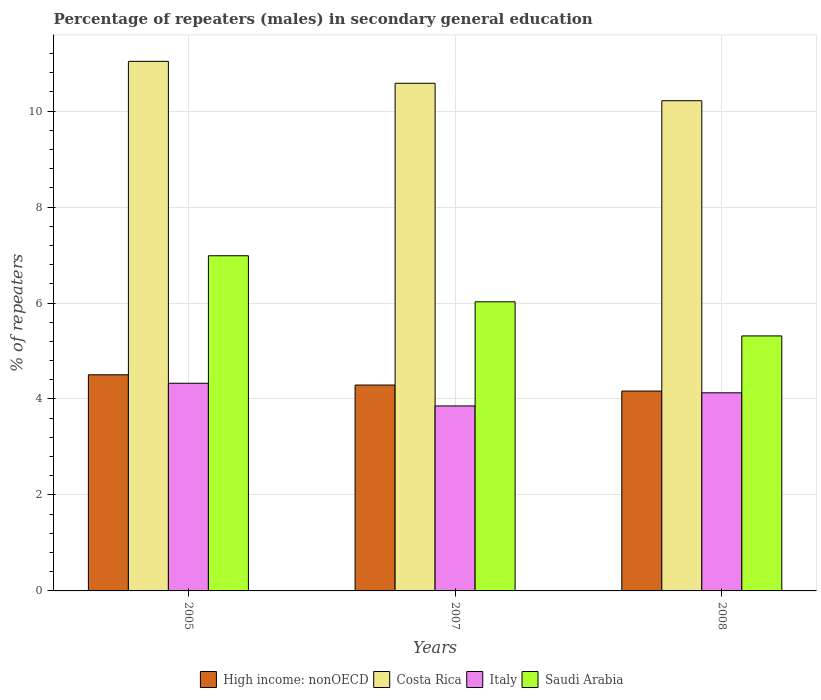How many different coloured bars are there?
Your answer should be very brief. 4. How many groups of bars are there?
Your answer should be very brief. 3. What is the percentage of male repeaters in High income: nonOECD in 2007?
Keep it short and to the point. 4.29. Across all years, what is the maximum percentage of male repeaters in Costa Rica?
Provide a succinct answer. 11.04. Across all years, what is the minimum percentage of male repeaters in Italy?
Your response must be concise. 3.86. In which year was the percentage of male repeaters in High income: nonOECD minimum?
Your answer should be compact. 2008. What is the total percentage of male repeaters in Italy in the graph?
Your response must be concise. 12.31. What is the difference between the percentage of male repeaters in Saudi Arabia in 2005 and that in 2007?
Give a very brief answer. 0.96. What is the difference between the percentage of male repeaters in Saudi Arabia in 2007 and the percentage of male repeaters in Italy in 2005?
Your answer should be very brief. 1.7. What is the average percentage of male repeaters in High income: nonOECD per year?
Offer a very short reply. 4.32. In the year 2007, what is the difference between the percentage of male repeaters in Saudi Arabia and percentage of male repeaters in Italy?
Your response must be concise. 2.17. What is the ratio of the percentage of male repeaters in High income: nonOECD in 2005 to that in 2007?
Your answer should be very brief. 1.05. Is the percentage of male repeaters in Costa Rica in 2007 less than that in 2008?
Your answer should be compact. No. What is the difference between the highest and the second highest percentage of male repeaters in High income: nonOECD?
Your answer should be compact. 0.21. What is the difference between the highest and the lowest percentage of male repeaters in Costa Rica?
Your answer should be very brief. 0.82. Is the sum of the percentage of male repeaters in High income: nonOECD in 2007 and 2008 greater than the maximum percentage of male repeaters in Costa Rica across all years?
Your response must be concise. No. Is it the case that in every year, the sum of the percentage of male repeaters in Italy and percentage of male repeaters in Costa Rica is greater than the sum of percentage of male repeaters in Saudi Arabia and percentage of male repeaters in High income: nonOECD?
Provide a short and direct response. Yes. What does the 1st bar from the right in 2008 represents?
Make the answer very short. Saudi Arabia. How many years are there in the graph?
Keep it short and to the point. 3. Are the values on the major ticks of Y-axis written in scientific E-notation?
Make the answer very short. No. Where does the legend appear in the graph?
Offer a very short reply. Bottom center. How are the legend labels stacked?
Make the answer very short. Horizontal. What is the title of the graph?
Make the answer very short. Percentage of repeaters (males) in secondary general education. Does "Trinidad and Tobago" appear as one of the legend labels in the graph?
Ensure brevity in your answer.  No. What is the label or title of the Y-axis?
Offer a very short reply. % of repeaters. What is the % of repeaters in High income: nonOECD in 2005?
Keep it short and to the point. 4.5. What is the % of repeaters of Costa Rica in 2005?
Give a very brief answer. 11.04. What is the % of repeaters of Italy in 2005?
Provide a succinct answer. 4.33. What is the % of repeaters in Saudi Arabia in 2005?
Your answer should be compact. 6.99. What is the % of repeaters of High income: nonOECD in 2007?
Your answer should be compact. 4.29. What is the % of repeaters of Costa Rica in 2007?
Offer a very short reply. 10.58. What is the % of repeaters of Italy in 2007?
Provide a succinct answer. 3.86. What is the % of repeaters in Saudi Arabia in 2007?
Give a very brief answer. 6.03. What is the % of repeaters of High income: nonOECD in 2008?
Offer a very short reply. 4.17. What is the % of repeaters in Costa Rica in 2008?
Provide a succinct answer. 10.22. What is the % of repeaters of Italy in 2008?
Your response must be concise. 4.13. What is the % of repeaters of Saudi Arabia in 2008?
Your response must be concise. 5.31. Across all years, what is the maximum % of repeaters in High income: nonOECD?
Your response must be concise. 4.5. Across all years, what is the maximum % of repeaters of Costa Rica?
Your answer should be compact. 11.04. Across all years, what is the maximum % of repeaters of Italy?
Your answer should be compact. 4.33. Across all years, what is the maximum % of repeaters of Saudi Arabia?
Make the answer very short. 6.99. Across all years, what is the minimum % of repeaters of High income: nonOECD?
Give a very brief answer. 4.17. Across all years, what is the minimum % of repeaters of Costa Rica?
Give a very brief answer. 10.22. Across all years, what is the minimum % of repeaters of Italy?
Make the answer very short. 3.86. Across all years, what is the minimum % of repeaters of Saudi Arabia?
Provide a succinct answer. 5.31. What is the total % of repeaters in High income: nonOECD in the graph?
Give a very brief answer. 12.96. What is the total % of repeaters in Costa Rica in the graph?
Keep it short and to the point. 31.83. What is the total % of repeaters of Italy in the graph?
Your response must be concise. 12.31. What is the total % of repeaters in Saudi Arabia in the graph?
Offer a terse response. 18.32. What is the difference between the % of repeaters of High income: nonOECD in 2005 and that in 2007?
Provide a succinct answer. 0.21. What is the difference between the % of repeaters in Costa Rica in 2005 and that in 2007?
Ensure brevity in your answer.  0.46. What is the difference between the % of repeaters in Italy in 2005 and that in 2007?
Offer a very short reply. 0.47. What is the difference between the % of repeaters of Saudi Arabia in 2005 and that in 2007?
Offer a very short reply. 0.96. What is the difference between the % of repeaters of High income: nonOECD in 2005 and that in 2008?
Offer a very short reply. 0.34. What is the difference between the % of repeaters of Costa Rica in 2005 and that in 2008?
Offer a terse response. 0.82. What is the difference between the % of repeaters of Italy in 2005 and that in 2008?
Give a very brief answer. 0.2. What is the difference between the % of repeaters in Saudi Arabia in 2005 and that in 2008?
Keep it short and to the point. 1.67. What is the difference between the % of repeaters of High income: nonOECD in 2007 and that in 2008?
Offer a terse response. 0.13. What is the difference between the % of repeaters in Costa Rica in 2007 and that in 2008?
Give a very brief answer. 0.36. What is the difference between the % of repeaters of Italy in 2007 and that in 2008?
Provide a succinct answer. -0.27. What is the difference between the % of repeaters in Saudi Arabia in 2007 and that in 2008?
Ensure brevity in your answer.  0.71. What is the difference between the % of repeaters in High income: nonOECD in 2005 and the % of repeaters in Costa Rica in 2007?
Offer a very short reply. -6.08. What is the difference between the % of repeaters in High income: nonOECD in 2005 and the % of repeaters in Italy in 2007?
Offer a very short reply. 0.65. What is the difference between the % of repeaters of High income: nonOECD in 2005 and the % of repeaters of Saudi Arabia in 2007?
Your answer should be very brief. -1.52. What is the difference between the % of repeaters of Costa Rica in 2005 and the % of repeaters of Italy in 2007?
Provide a succinct answer. 7.18. What is the difference between the % of repeaters of Costa Rica in 2005 and the % of repeaters of Saudi Arabia in 2007?
Your answer should be very brief. 5.01. What is the difference between the % of repeaters of Italy in 2005 and the % of repeaters of Saudi Arabia in 2007?
Keep it short and to the point. -1.7. What is the difference between the % of repeaters in High income: nonOECD in 2005 and the % of repeaters in Costa Rica in 2008?
Your answer should be very brief. -5.71. What is the difference between the % of repeaters in High income: nonOECD in 2005 and the % of repeaters in Italy in 2008?
Your answer should be very brief. 0.38. What is the difference between the % of repeaters of High income: nonOECD in 2005 and the % of repeaters of Saudi Arabia in 2008?
Your response must be concise. -0.81. What is the difference between the % of repeaters of Costa Rica in 2005 and the % of repeaters of Italy in 2008?
Offer a very short reply. 6.91. What is the difference between the % of repeaters of Costa Rica in 2005 and the % of repeaters of Saudi Arabia in 2008?
Your answer should be compact. 5.72. What is the difference between the % of repeaters in Italy in 2005 and the % of repeaters in Saudi Arabia in 2008?
Your answer should be very brief. -0.99. What is the difference between the % of repeaters in High income: nonOECD in 2007 and the % of repeaters in Costa Rica in 2008?
Your answer should be very brief. -5.93. What is the difference between the % of repeaters of High income: nonOECD in 2007 and the % of repeaters of Italy in 2008?
Keep it short and to the point. 0.16. What is the difference between the % of repeaters in High income: nonOECD in 2007 and the % of repeaters in Saudi Arabia in 2008?
Your answer should be very brief. -1.02. What is the difference between the % of repeaters of Costa Rica in 2007 and the % of repeaters of Italy in 2008?
Offer a terse response. 6.45. What is the difference between the % of repeaters in Costa Rica in 2007 and the % of repeaters in Saudi Arabia in 2008?
Your answer should be compact. 5.27. What is the difference between the % of repeaters in Italy in 2007 and the % of repeaters in Saudi Arabia in 2008?
Keep it short and to the point. -1.46. What is the average % of repeaters in High income: nonOECD per year?
Your response must be concise. 4.32. What is the average % of repeaters of Costa Rica per year?
Your answer should be very brief. 10.61. What is the average % of repeaters of Italy per year?
Offer a terse response. 4.1. What is the average % of repeaters of Saudi Arabia per year?
Offer a very short reply. 6.11. In the year 2005, what is the difference between the % of repeaters in High income: nonOECD and % of repeaters in Costa Rica?
Provide a short and direct response. -6.53. In the year 2005, what is the difference between the % of repeaters in High income: nonOECD and % of repeaters in Italy?
Your response must be concise. 0.18. In the year 2005, what is the difference between the % of repeaters in High income: nonOECD and % of repeaters in Saudi Arabia?
Your answer should be compact. -2.48. In the year 2005, what is the difference between the % of repeaters of Costa Rica and % of repeaters of Italy?
Your answer should be compact. 6.71. In the year 2005, what is the difference between the % of repeaters in Costa Rica and % of repeaters in Saudi Arabia?
Make the answer very short. 4.05. In the year 2005, what is the difference between the % of repeaters in Italy and % of repeaters in Saudi Arabia?
Offer a very short reply. -2.66. In the year 2007, what is the difference between the % of repeaters in High income: nonOECD and % of repeaters in Costa Rica?
Your answer should be compact. -6.29. In the year 2007, what is the difference between the % of repeaters of High income: nonOECD and % of repeaters of Italy?
Your answer should be very brief. 0.44. In the year 2007, what is the difference between the % of repeaters in High income: nonOECD and % of repeaters in Saudi Arabia?
Provide a short and direct response. -1.73. In the year 2007, what is the difference between the % of repeaters in Costa Rica and % of repeaters in Italy?
Provide a succinct answer. 6.72. In the year 2007, what is the difference between the % of repeaters in Costa Rica and % of repeaters in Saudi Arabia?
Provide a short and direct response. 4.55. In the year 2007, what is the difference between the % of repeaters of Italy and % of repeaters of Saudi Arabia?
Your response must be concise. -2.17. In the year 2008, what is the difference between the % of repeaters in High income: nonOECD and % of repeaters in Costa Rica?
Provide a succinct answer. -6.05. In the year 2008, what is the difference between the % of repeaters in High income: nonOECD and % of repeaters in Italy?
Provide a succinct answer. 0.04. In the year 2008, what is the difference between the % of repeaters in High income: nonOECD and % of repeaters in Saudi Arabia?
Give a very brief answer. -1.15. In the year 2008, what is the difference between the % of repeaters of Costa Rica and % of repeaters of Italy?
Offer a very short reply. 6.09. In the year 2008, what is the difference between the % of repeaters in Costa Rica and % of repeaters in Saudi Arabia?
Keep it short and to the point. 4.9. In the year 2008, what is the difference between the % of repeaters in Italy and % of repeaters in Saudi Arabia?
Offer a very short reply. -1.19. What is the ratio of the % of repeaters of High income: nonOECD in 2005 to that in 2007?
Offer a very short reply. 1.05. What is the ratio of the % of repeaters in Costa Rica in 2005 to that in 2007?
Ensure brevity in your answer.  1.04. What is the ratio of the % of repeaters in Italy in 2005 to that in 2007?
Keep it short and to the point. 1.12. What is the ratio of the % of repeaters in Saudi Arabia in 2005 to that in 2007?
Make the answer very short. 1.16. What is the ratio of the % of repeaters of High income: nonOECD in 2005 to that in 2008?
Provide a succinct answer. 1.08. What is the ratio of the % of repeaters in Costa Rica in 2005 to that in 2008?
Your response must be concise. 1.08. What is the ratio of the % of repeaters in Italy in 2005 to that in 2008?
Keep it short and to the point. 1.05. What is the ratio of the % of repeaters of Saudi Arabia in 2005 to that in 2008?
Ensure brevity in your answer.  1.31. What is the ratio of the % of repeaters of High income: nonOECD in 2007 to that in 2008?
Offer a terse response. 1.03. What is the ratio of the % of repeaters of Costa Rica in 2007 to that in 2008?
Keep it short and to the point. 1.04. What is the ratio of the % of repeaters in Italy in 2007 to that in 2008?
Keep it short and to the point. 0.93. What is the ratio of the % of repeaters of Saudi Arabia in 2007 to that in 2008?
Offer a terse response. 1.13. What is the difference between the highest and the second highest % of repeaters of High income: nonOECD?
Offer a very short reply. 0.21. What is the difference between the highest and the second highest % of repeaters in Costa Rica?
Offer a terse response. 0.46. What is the difference between the highest and the second highest % of repeaters in Italy?
Make the answer very short. 0.2. What is the difference between the highest and the second highest % of repeaters in Saudi Arabia?
Provide a short and direct response. 0.96. What is the difference between the highest and the lowest % of repeaters of High income: nonOECD?
Keep it short and to the point. 0.34. What is the difference between the highest and the lowest % of repeaters in Costa Rica?
Provide a succinct answer. 0.82. What is the difference between the highest and the lowest % of repeaters of Italy?
Provide a short and direct response. 0.47. What is the difference between the highest and the lowest % of repeaters of Saudi Arabia?
Give a very brief answer. 1.67. 